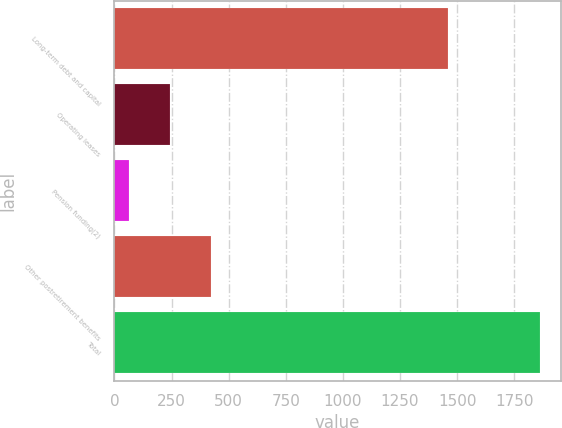Convert chart to OTSL. <chart><loc_0><loc_0><loc_500><loc_500><bar_chart><fcel>Long-term debt and capital<fcel>Operating leases<fcel>Pension funding(2)<fcel>Other postretirement benefits<fcel>Total<nl><fcel>1462<fcel>244.6<fcel>65<fcel>424.2<fcel>1861<nl></chart> 